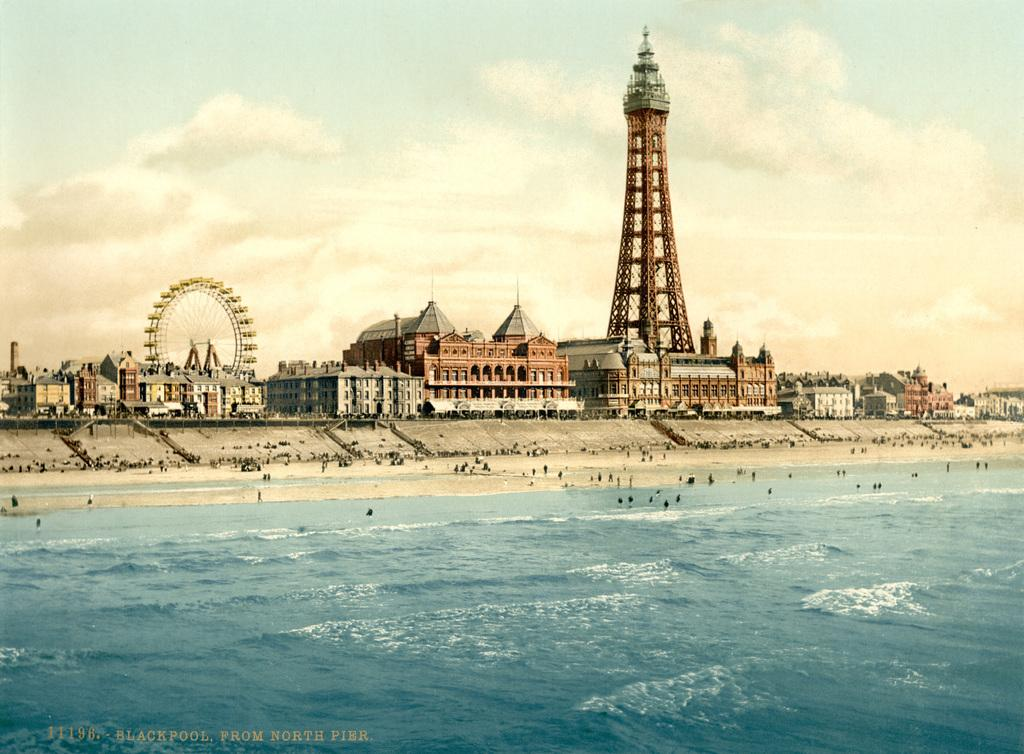What is the primary element in the image? There is water in the image. What are the people in the image doing? There are people in the water and people on the beach. What can be seen in the background of the image? There are buildings, a tower, a giant wheel, and the sky visible in the background of the image. What type of drum can be heard playing in the image? There is no drum present or audible in the image. How high are the waves in the image? There are no waves mentioned or visible in the image; it features people in the water and on the beach. 